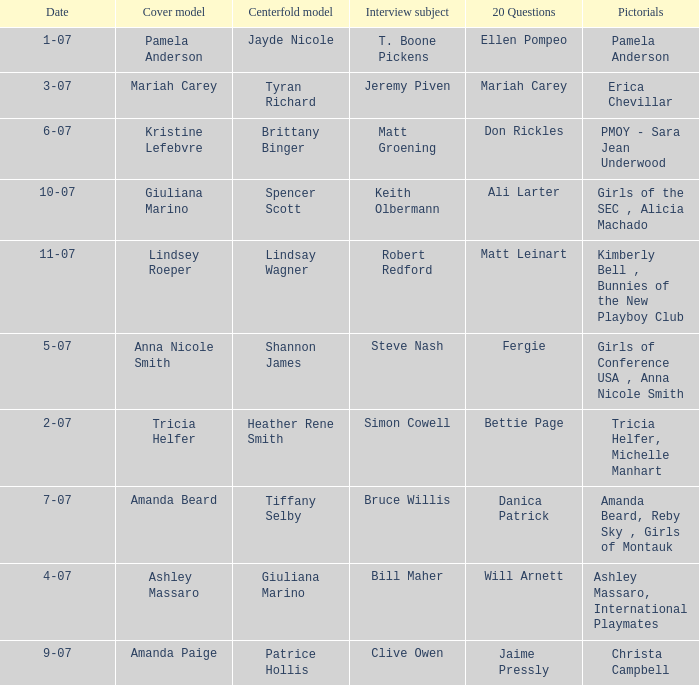Who answered the 20 questions on 10-07? Ali Larter. 